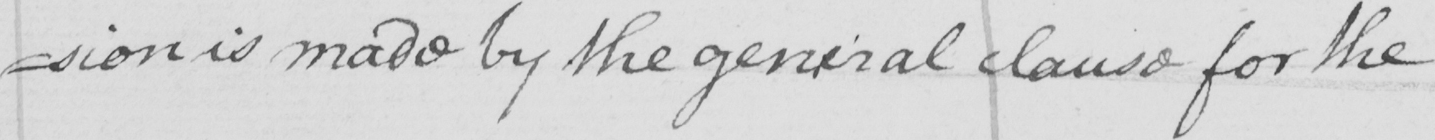Please provide the text content of this handwritten line. =sion is made by the general clause for the 